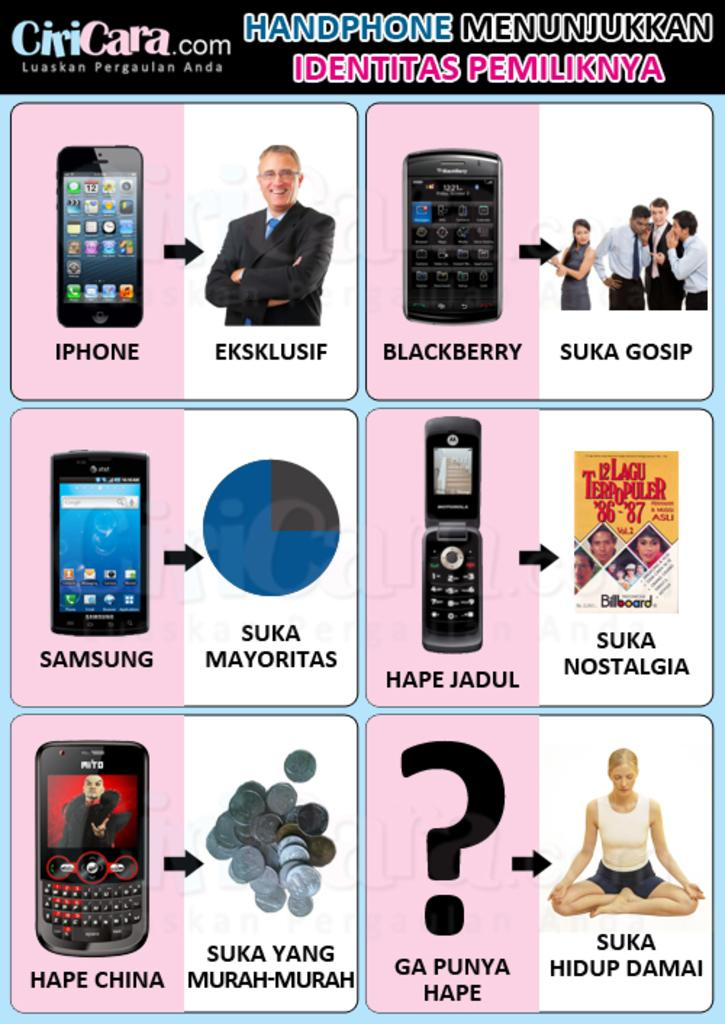What is the main subject of the poster in the image? The poster contains images of mobiles and persons. What type of images are featured on the poster? The poster contains images of mobiles and persons. Is there any text on the poster? Yes, there is text on the poster. Where can we find the park and chairs mentioned in the poster? There is no mention of a park or chairs in the poster; it only contains images of mobiles and persons, along with text. 